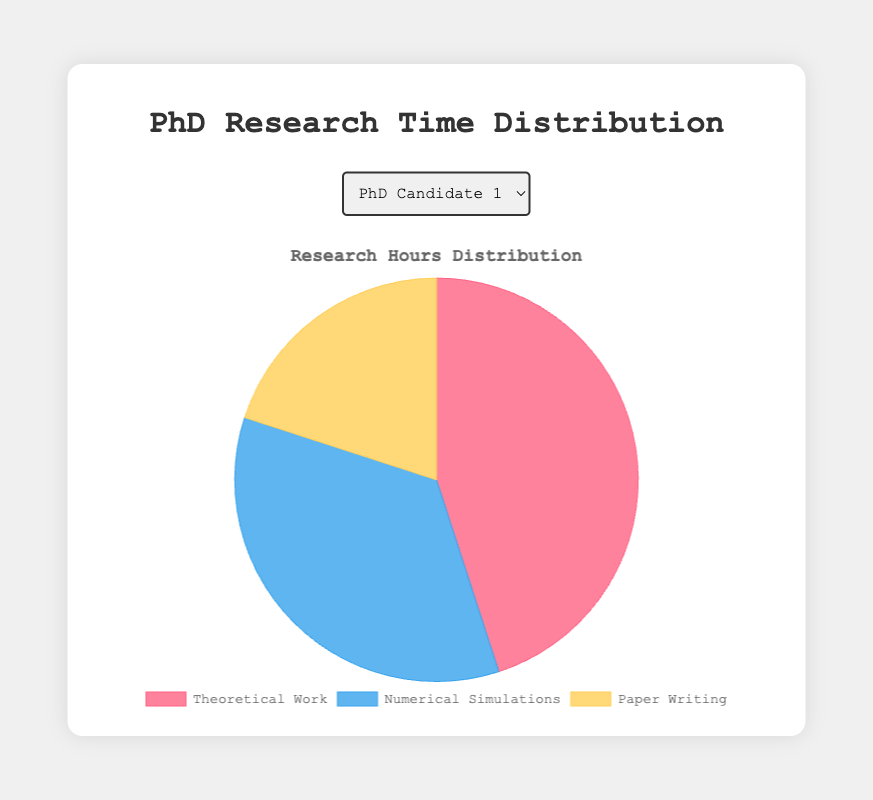what is the percentage of time spent by PhD Candidate 4 on theoretical work? The pie chart shows the distribution of time for PhD Candidate 4. From the chart, we can see that theoretical work takes 60% of the total time allocated.
Answer: 60% Compare the time spent on numerical simulations between PhD Candidate 2 and PhD Candidate 5. By looking at the chart, we see that Numerical Simulations take up 30% of the time for PhD Candidate 2 and 25% for PhD Candidate 5. Hence, PhD Candidate 2 spends more time on numerical simulations.
Answer: PhD Candidate 2 spends more time What is the total percentage of time spent on paper writing by all candidates? From the data, all candidates spend 20% of their time on paper writing. To find the total, we just sum 20% five times. 20% + 20% + 20% + 20% + 20% = 100%.
Answer: 100% Which candidate dedicates the highest percentage of their time to theoretical work? By comparing the slices of the pie chart, PhD Candidate 4 dedicates 60% of their time to theoretical work, which is the highest percentage among all candidates.
Answer: PhD Candidate 4 How does the distribution of research hours for PhD Candidate 3 compare to PhD Candidate 1 in terms of numerical simulations and paper writing combined? PhD Candidate 3 dedicates 40% to numerical simulations and 20% to paper writing, making a total of 60%. PhD Candidate 1 dedicates 35% to numerical simulations and 20% to paper writing, making a total of 55%.
Answer: PhD Candidate 3 spends more What is the average percentage of time spent on numerical simulations by all candidates? To find the average percentage of time spent on numerical simulations, sum all the percentages and divide by the number of candidates. (35 + 30 + 40 + 20 + 25)/5 = 30%
Answer: 30% Identify the candidate who has the most balanced distribution of research hours. The most balanced distribution would imply the closest percentages among theoretical work, numerical simulations, and paper writing. PhD Candidate 3 has 40%, 40%, and 20% respectively, which appears most balanced.
Answer: PhD Candidate 3 How much more time does PhD Candidate 4 spend on theoretical work compared to numerical simulations? PhD Candidate 4 spends 60% on theoretical work and 20% on numerical simulations. The difference is 60% - 20% = 40%.
Answer: 40% more 